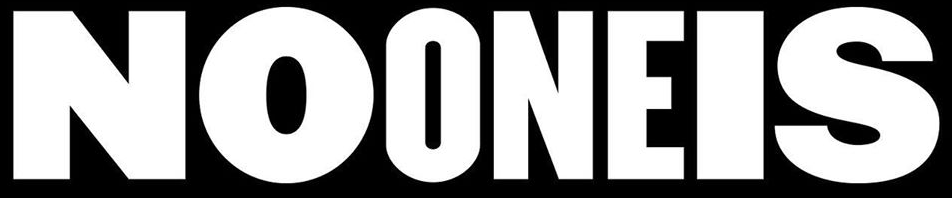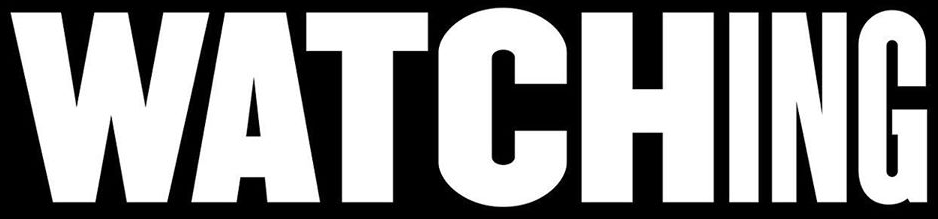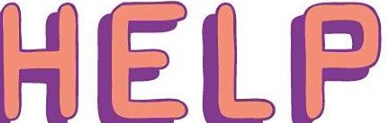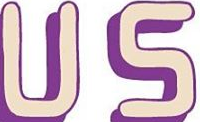What text is displayed in these images sequentially, separated by a semicolon? NOONEIS; WATCHING; HELP; US 